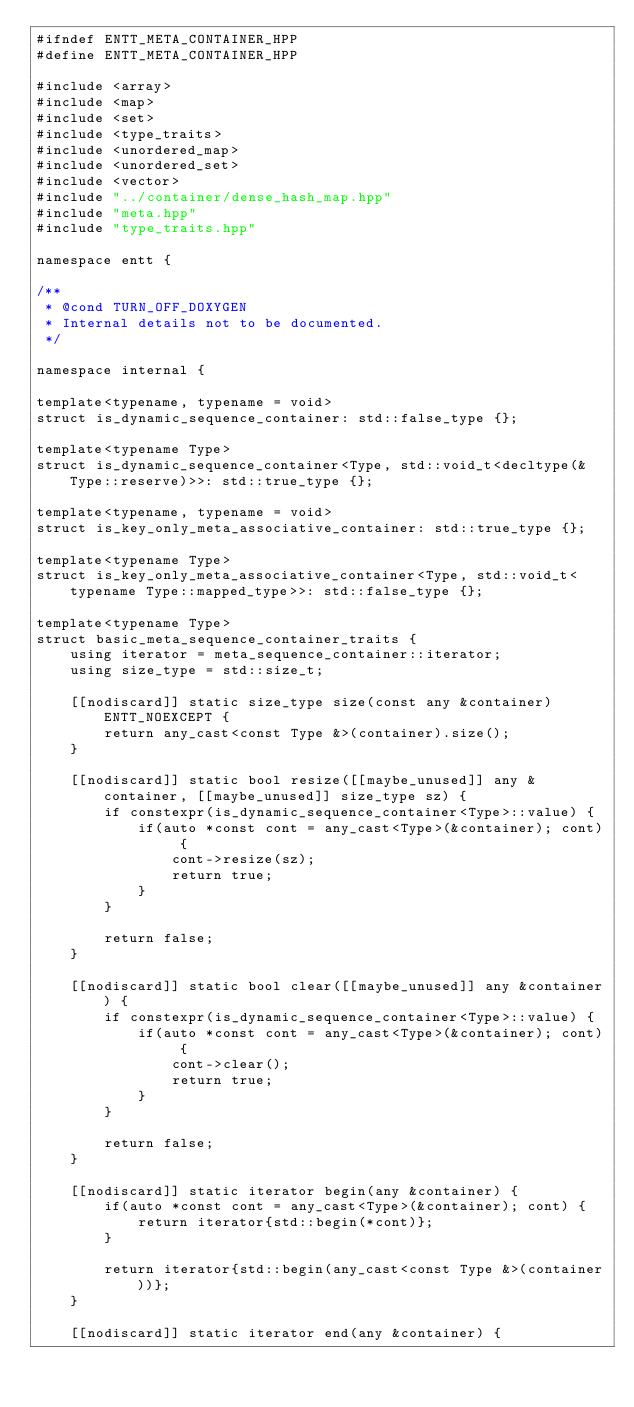Convert code to text. <code><loc_0><loc_0><loc_500><loc_500><_C++_>#ifndef ENTT_META_CONTAINER_HPP
#define ENTT_META_CONTAINER_HPP

#include <array>
#include <map>
#include <set>
#include <type_traits>
#include <unordered_map>
#include <unordered_set>
#include <vector>
#include "../container/dense_hash_map.hpp"
#include "meta.hpp"
#include "type_traits.hpp"

namespace entt {

/**
 * @cond TURN_OFF_DOXYGEN
 * Internal details not to be documented.
 */

namespace internal {

template<typename, typename = void>
struct is_dynamic_sequence_container: std::false_type {};

template<typename Type>
struct is_dynamic_sequence_container<Type, std::void_t<decltype(&Type::reserve)>>: std::true_type {};

template<typename, typename = void>
struct is_key_only_meta_associative_container: std::true_type {};

template<typename Type>
struct is_key_only_meta_associative_container<Type, std::void_t<typename Type::mapped_type>>: std::false_type {};

template<typename Type>
struct basic_meta_sequence_container_traits {
    using iterator = meta_sequence_container::iterator;
    using size_type = std::size_t;

    [[nodiscard]] static size_type size(const any &container) ENTT_NOEXCEPT {
        return any_cast<const Type &>(container).size();
    }

    [[nodiscard]] static bool resize([[maybe_unused]] any &container, [[maybe_unused]] size_type sz) {
        if constexpr(is_dynamic_sequence_container<Type>::value) {
            if(auto *const cont = any_cast<Type>(&container); cont) {
                cont->resize(sz);
                return true;
            }
        }

        return false;
    }

    [[nodiscard]] static bool clear([[maybe_unused]] any &container) {
        if constexpr(is_dynamic_sequence_container<Type>::value) {
            if(auto *const cont = any_cast<Type>(&container); cont) {
                cont->clear();
                return true;
            }
        }

        return false;
    }

    [[nodiscard]] static iterator begin(any &container) {
        if(auto *const cont = any_cast<Type>(&container); cont) {
            return iterator{std::begin(*cont)};
        }

        return iterator{std::begin(any_cast<const Type &>(container))};
    }

    [[nodiscard]] static iterator end(any &container) {</code> 